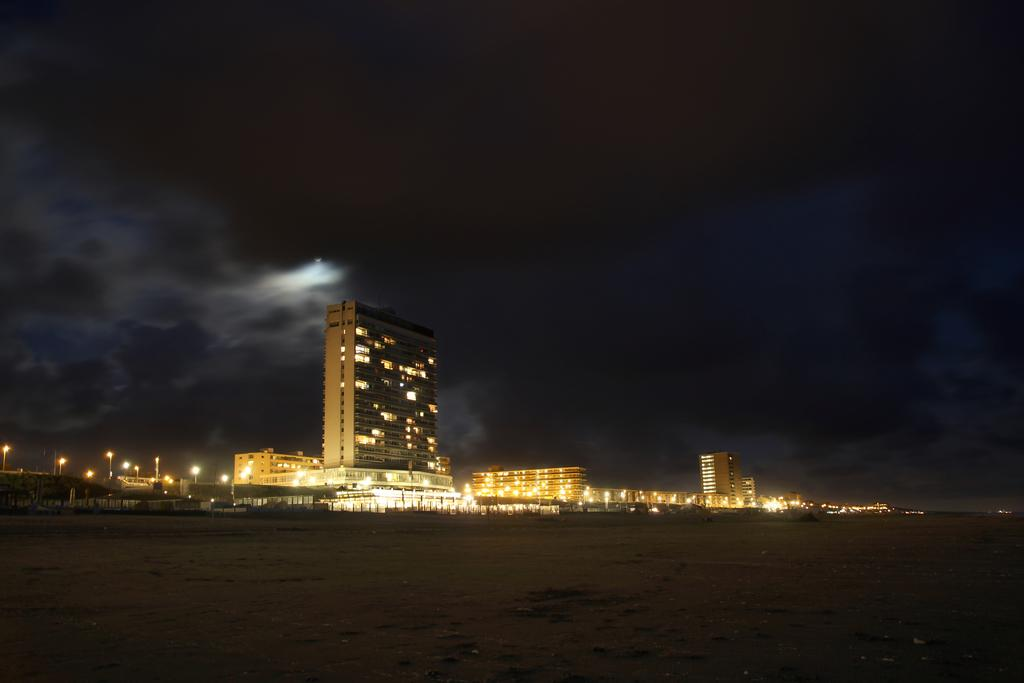What type of structures can be seen in the image? There are buildings and towers in the image. What type of lighting is present in the image? Street lights are visible in the image. What type of transportation can be seen in the image? Vehicles are present on the road in the image. What architectural features can be seen in the buildings? Windows are visible in the image. What type of surface is visible in the image? The ground is visible in the image. What type of vegetation is present in the image? Trees are present in the image. What type of barrier is present in the image? There is a fence in the image. What part of the natural environment is visible in the image? The sky is visible in the image. What type of edge can be seen on the knife in the image? There is no knife present in the image. What type of view can be seen from the top of the tower in the image? The image does not show a view from the top of the tower, as it only provides a ground-level perspective. 